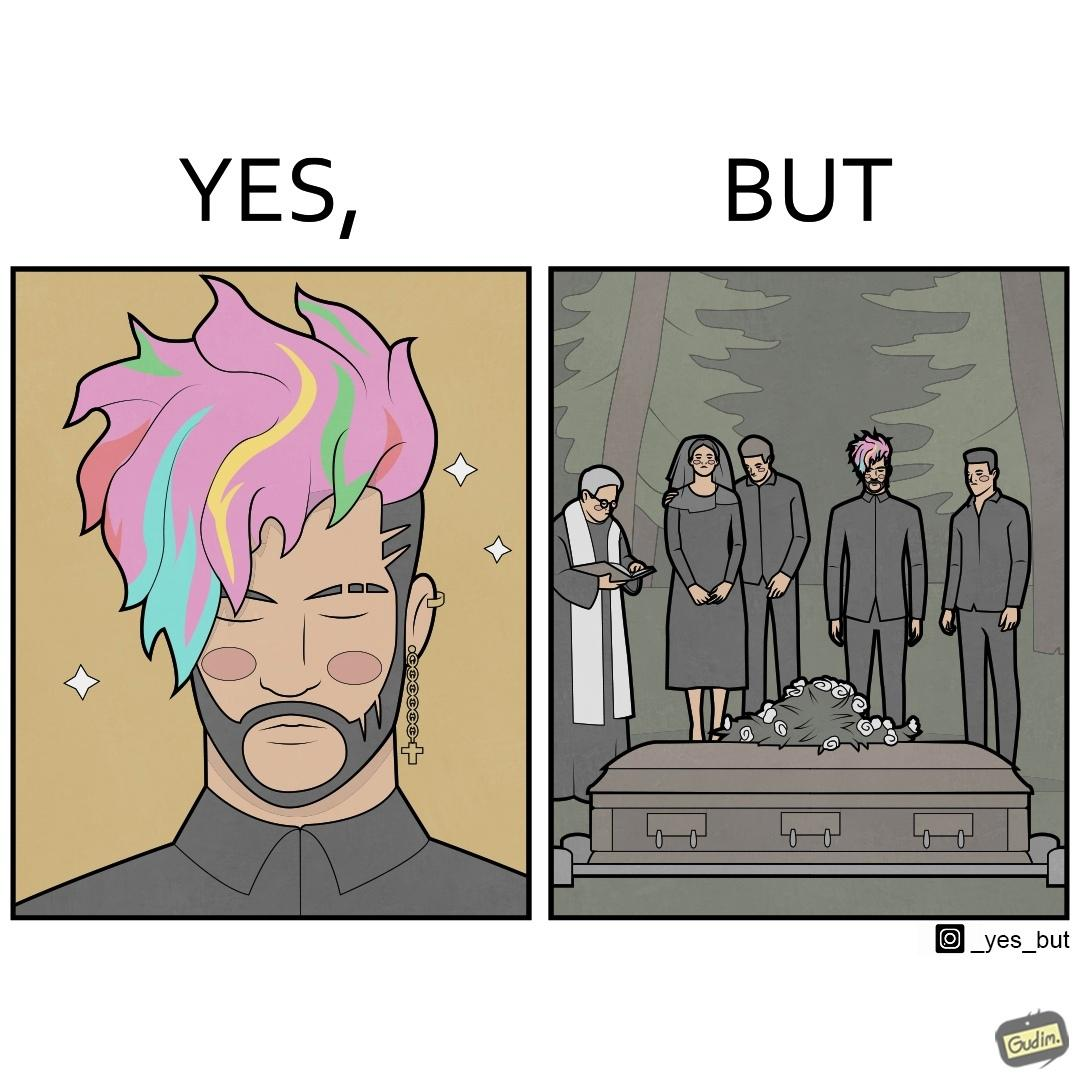What is shown in the left half versus the right half of this image? In the left part of the image: a person with colorful hairstyle, stylish beard at ear piercings In the right part of the image: a group of persons at the death ceremony of some person performing the last rituals 